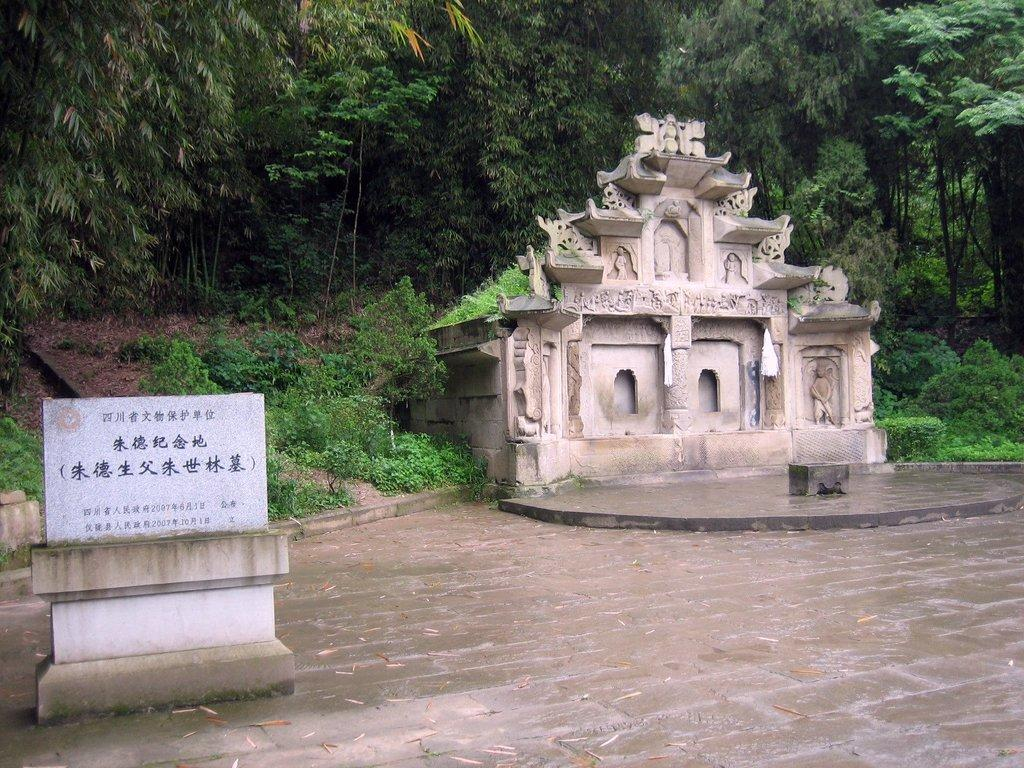What is the main object in the front of the image? There is a stone with text in the front of the image. What can be seen in the background of the image? There is a structure and trees in the background of the image. What type of mask is being worn by the idea in the image? There is no idea or mask present in the image; it features a stone with text and a background with a structure and trees. 